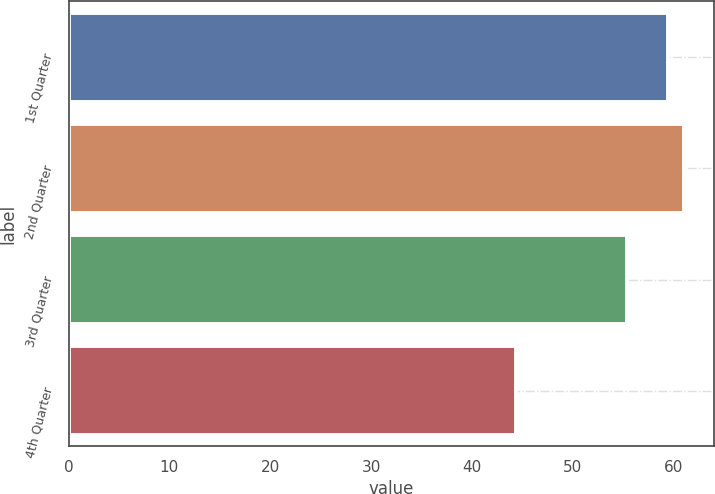Convert chart. <chart><loc_0><loc_0><loc_500><loc_500><bar_chart><fcel>1st Quarter<fcel>2nd Quarter<fcel>3rd Quarter<fcel>4th Quarter<nl><fcel>59.46<fcel>60.99<fcel>55.34<fcel>44.37<nl></chart> 